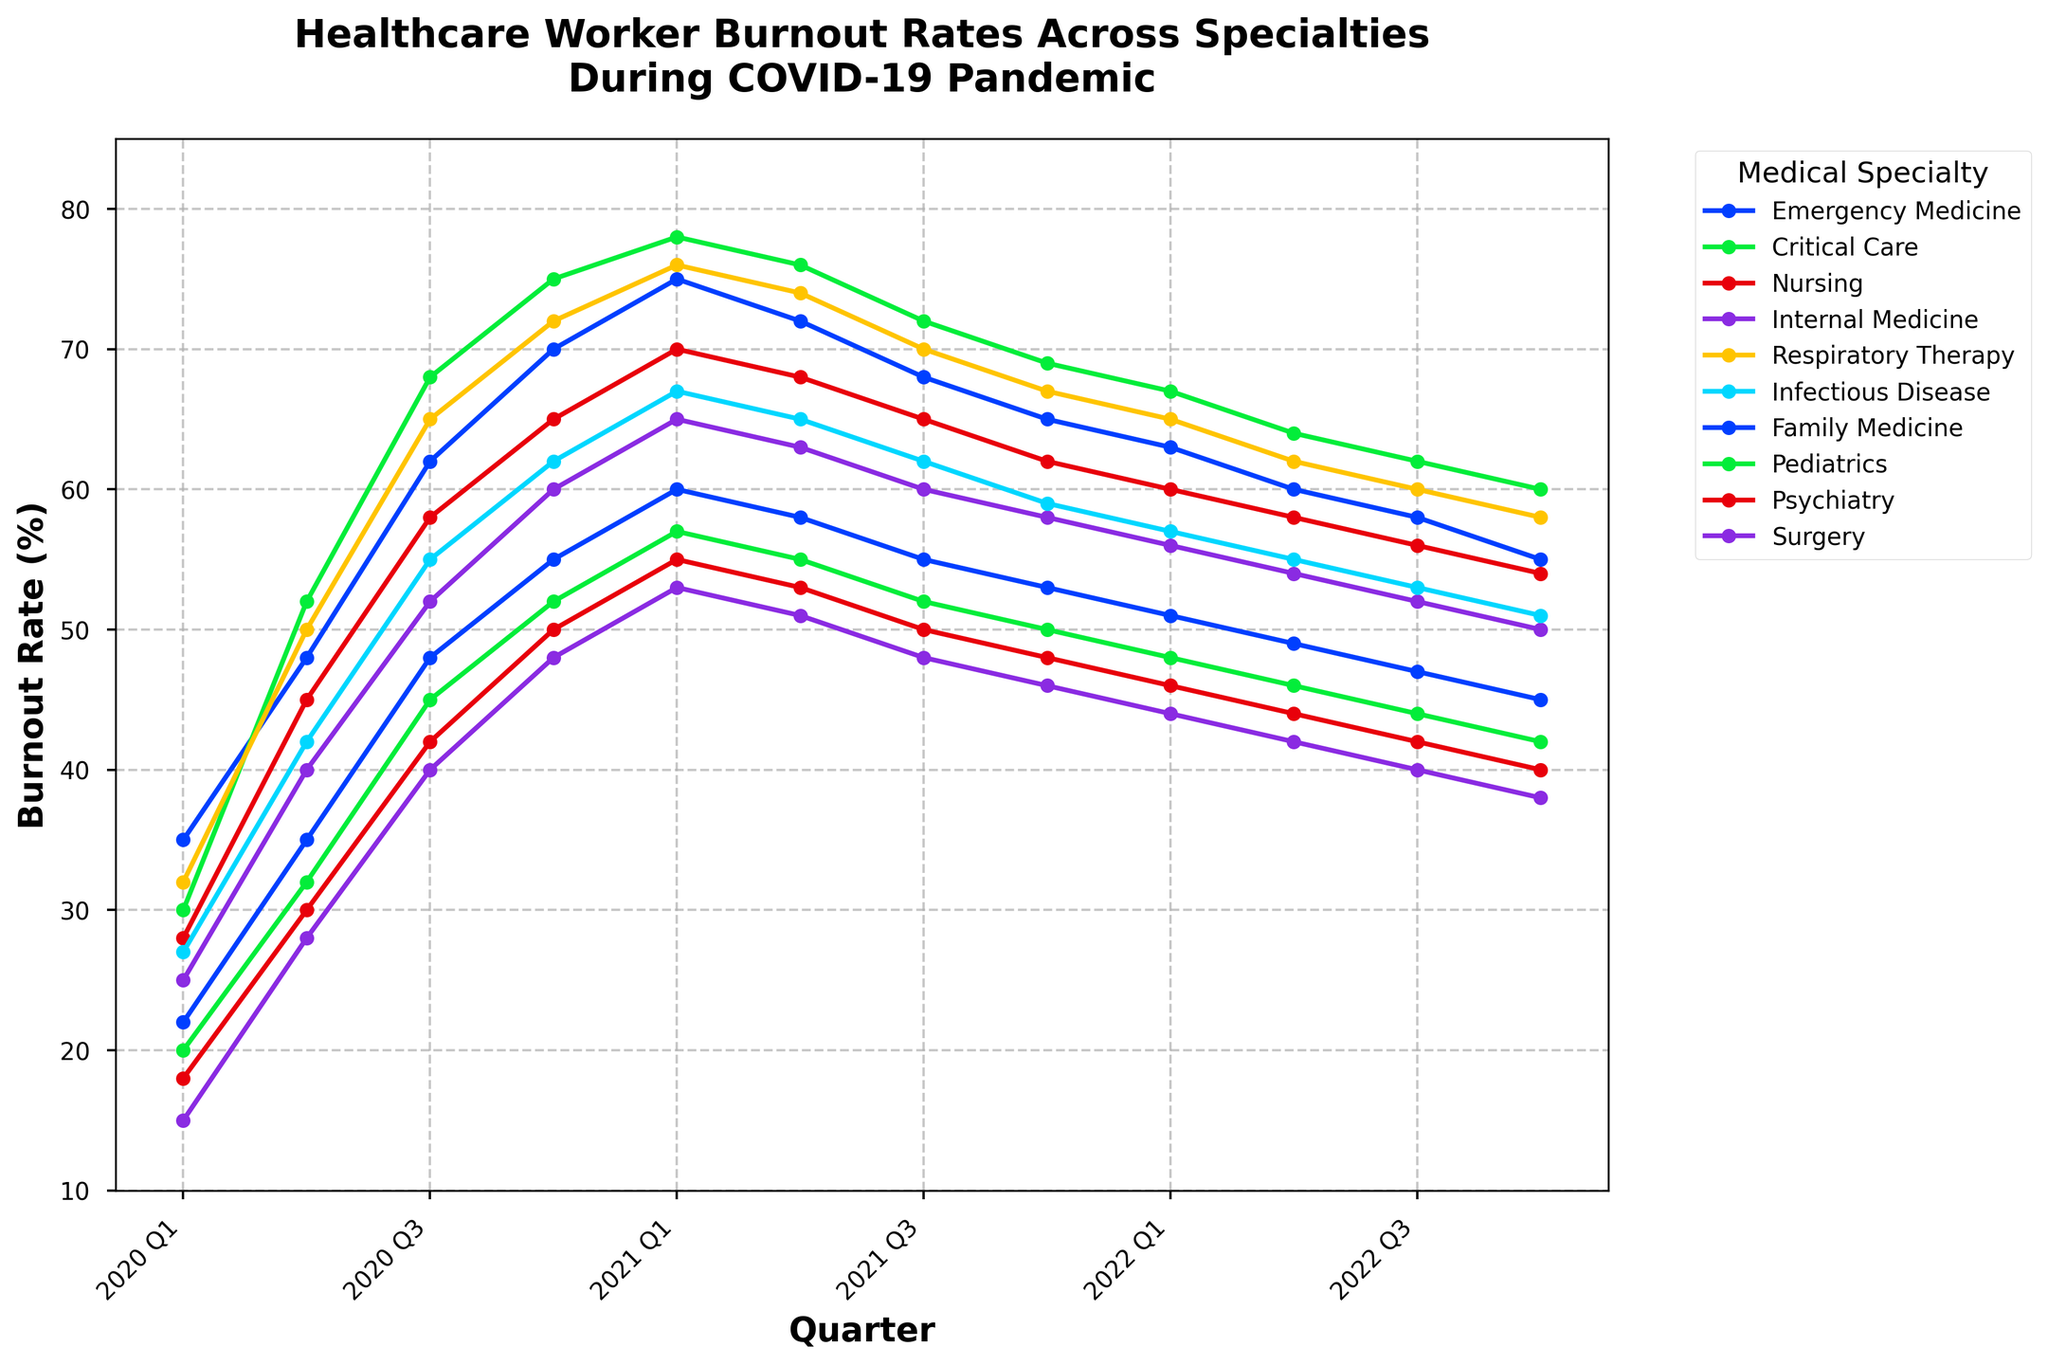What medical specialty had the highest burnout rate at its peak during the plotted period? Analyze the points on the line chart to identify the highest value and locate the corresponding specialty. Critical Care had the highest burnout rate at 78% in 2021 Q1.
Answer: Critical Care Which medical specialty had the most consistent decline in burnout rate from its peak to the end of 2022? Review each line for the specialty that shows a steady decline without fluctuating drastically. Emergency Medicine dropped consistently from 2020 Q4 to 2022 Q4.
Answer: Emergency Medicine By how much did the burnout rate for Surgery increase from 2020 Q1 to its peak? Identify the burnout rates for Surgery in 2020 Q1 and its peak, then calculate the difference. Surgery increased from 15% in 2020 Q1 to 53% in 2021 Q1, a difference of 38%.
Answer: 38% Which two specialties had similar burnout rates in 2022 Q4? Compare the endpoint values on the chart to find specialties with closely matching rates. Internal Medicine and Infectious Disease had similar burnout rates of 50% and 51% respectively.
Answer: Internal Medicine and Infectious Disease What was the overall trend for Pediatrics from the beginning to the end of the plotted period? Observe the line representing Pediatrics from the start to the end of the chart. Pediatrics went from 20% in 2020 Q1 and increased to 42% by 2022 Q4, indicating an overall increase.
Answer: Increase Did the burnout rate for Nursing ever exceed 70%? Check the points on the line corresponding to Nursing to determine if any points are greater than 70%. Nursing's burnout rate hit 70% in 2021 Q1 but did not exceed it.
Answer: No By what percentage did the burnout rate for Family Medicine change from its highest point to the end of 2022? Identify the highest burnout rate and the 2022 Q4 rate for Family Medicine, then calculate the percentage change. Family Medicine peaked at 60% in 2021 Q1 and decreased to 45% in 2022 Q4, a change of 25%.
Answer: 25% Which specialty experienced the largest increase in burnout rate in the shortest time? Look for the steepest part of any line to identify the largest and quickest increase. Critical Care increased from 52% in 2020 Q2 to 68% in 2020 Q3, the largest short-term increase.
Answer: Critical Care What specialty had a decrease in burnout rate each quarter from its highest point to 2022 Q4? Locate the peak burnout rate for each specialty and follow the line to 2022 Q4 to see if the rate decreases each quarter. Emergency Medicine had a continuous decrease after its peak in 2021 Q1 to 2022 Q4.
Answer: Emergency Medicine 